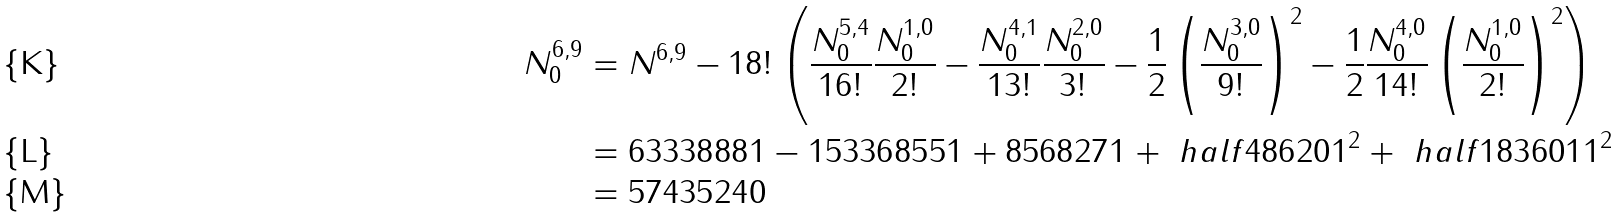Convert formula to latex. <formula><loc_0><loc_0><loc_500><loc_500>N _ { 0 } ^ { 6 , 9 } & = N ^ { 6 , 9 } - 1 8 ! \left ( \frac { N _ { 0 } ^ { 5 , 4 } } { 1 6 ! } \frac { N _ { 0 } ^ { 1 , 0 } } { 2 ! } - \frac { N _ { 0 } ^ { 4 , 1 } } { 1 3 ! } \frac { N _ { 0 } ^ { 2 , 0 } } { 3 ! } - \frac { 1 } { 2 } \left ( \frac { N _ { 0 } ^ { 3 , 0 } } { 9 ! } \right ) ^ { 2 } - \frac { 1 } { 2 } \frac { N _ { 0 } ^ { 4 , 0 } } { 1 4 ! } \left ( \frac { N _ { 0 } ^ { 1 , 0 } } { 2 ! } \right ) ^ { 2 } \right ) \\ & = 6 3 3 3 8 8 8 1 - 1 5 3 3 6 8 5 5 1 + 8 5 6 8 2 7 1 + \ h a l f 4 8 6 2 0 1 ^ { 2 } + \ h a l f 1 8 3 6 0 1 1 ^ { 2 } \\ & = 5 7 4 3 5 2 4 0</formula> 